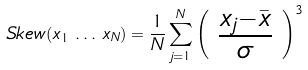Convert formula to latex. <formula><loc_0><loc_0><loc_500><loc_500>S k e w ( x _ { 1 } \, \dots \, x _ { N } ) = \frac { 1 } { N } \sum ^ { N } _ { j = 1 } \left ( \begin{array} { c } \frac { x _ { j } - \bar { x } } { \sigma } \end{array} \right ) ^ { 3 }</formula> 